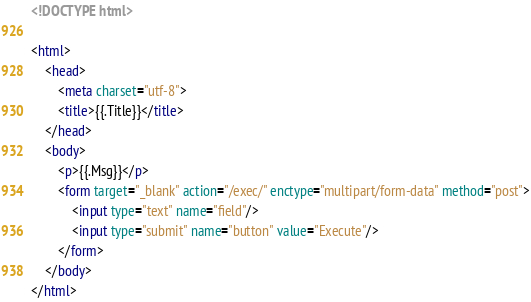<code> <loc_0><loc_0><loc_500><loc_500><_HTML_><!DOCTYPE html>

<html>
    <head>
        <meta charset="utf-8">
        <title>{{.Title}}</title>
    </head>
    <body>
        <p>{{.Msg}}</p>
        <form target="_blank" action="/exec/" enctype="multipart/form-data" method="post">
            <input type="text" name="field"/>
            <input type="submit" name="button" value="Execute"/>
        </form>
    </body>
</html>
</code> 